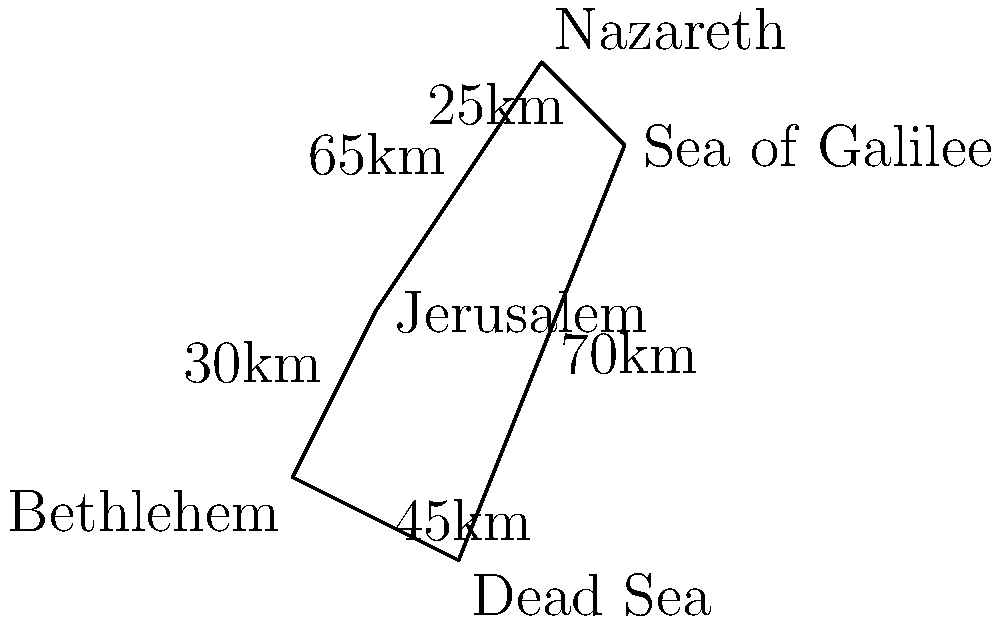As a travel writer planning a trip to the Holy Land, you want to visit Jerusalem, Bethlehem, the Dead Sea, the Sea of Galilee, and Nazareth. Given the map and distances between locations, what is the total distance (in km) of the most efficient route that starts and ends in Jerusalem, visiting each location exactly once? To find the most efficient route, we need to consider all possible paths and calculate their total distances. The problem is similar to the Traveling Salesman Problem. Given the limited number of locations, we can solve this manually:

1. Start in Jerusalem
2. The closest location is Bethlehem (30km)
3. From Bethlehem, the next closest is the Dead Sea (45km)
4. The Sea of Galilee is the next logical stop (70km)
5. Nazareth is close to the Sea of Galilee (25km)
6. Return to Jerusalem from Nazareth (65km)

The total distance of this route is:
$$ 30 + 45 + 70 + 25 + 65 = 235 \text{ km} $$

This route (Jerusalem → Bethlehem → Dead Sea → Sea of Galilee → Nazareth → Jerusalem) is the most efficient as it minimizes backtracking and takes advantage of the locations' proximity to each other.
Answer: 235 km 